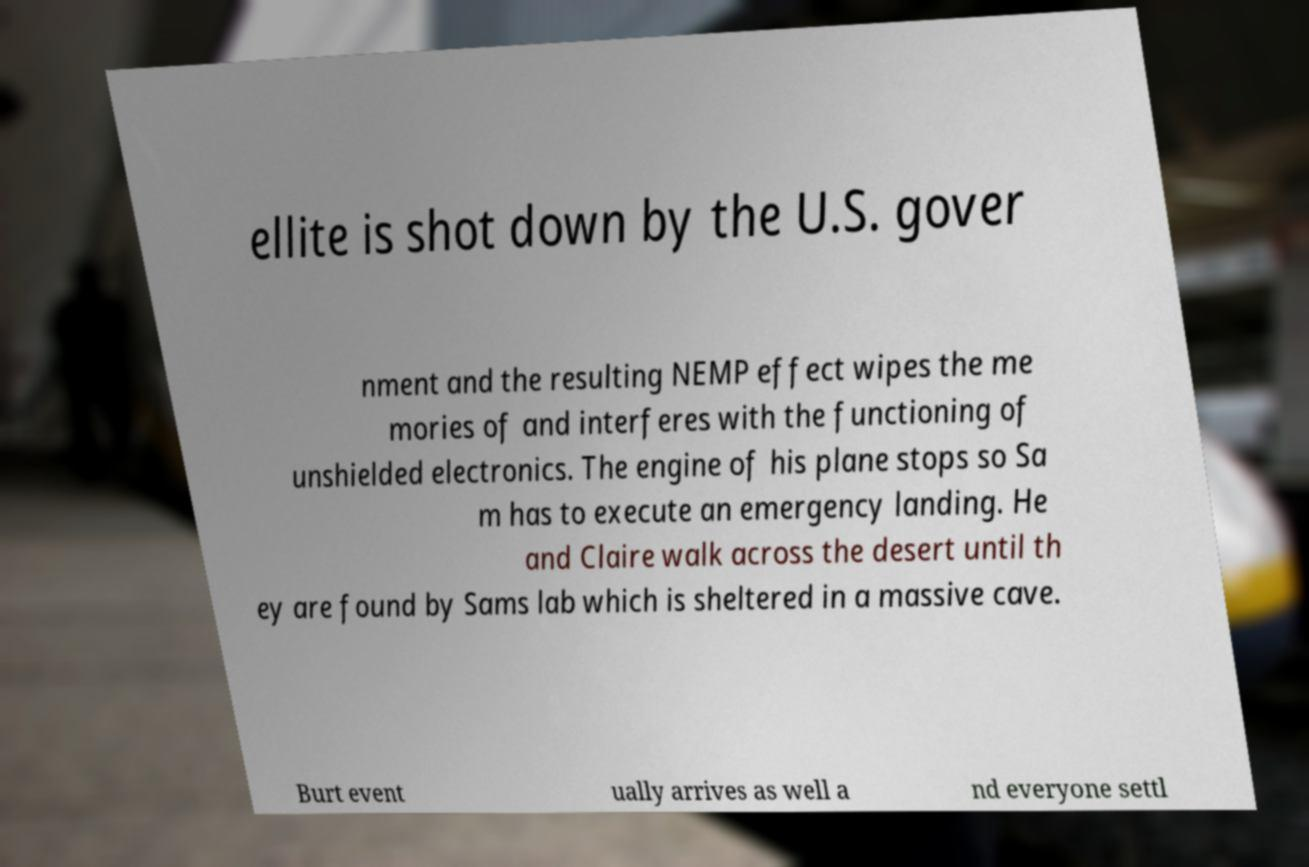Please read and relay the text visible in this image. What does it say? ellite is shot down by the U.S. gover nment and the resulting NEMP effect wipes the me mories of and interferes with the functioning of unshielded electronics. The engine of his plane stops so Sa m has to execute an emergency landing. He and Claire walk across the desert until th ey are found by Sams lab which is sheltered in a massive cave. Burt event ually arrives as well a nd everyone settl 